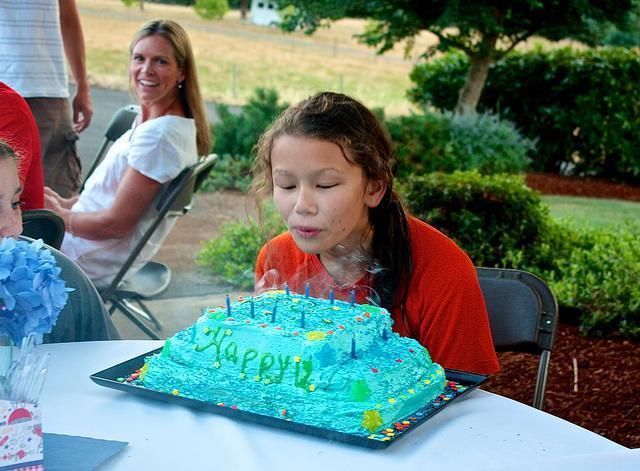How many candles are on the cake?
Give a very brief answer. 10. How many people are in the photo?
Give a very brief answer. 5. How many chairs are in the photo?
Give a very brief answer. 2. 